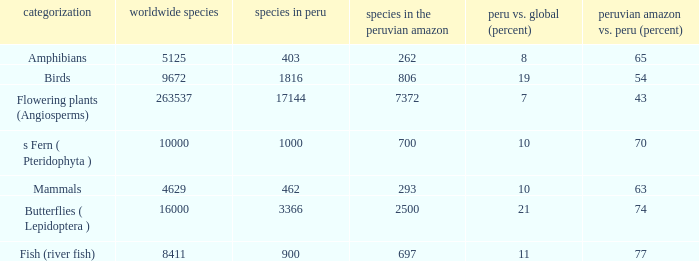What's the minimum species in the peruvian amazon with taxonomy s fern ( pteridophyta ) 700.0. 